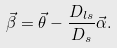<formula> <loc_0><loc_0><loc_500><loc_500>\vec { \beta } = \vec { \theta } - \frac { D _ { l s } } { D _ { s } } \vec { \alpha } .</formula> 